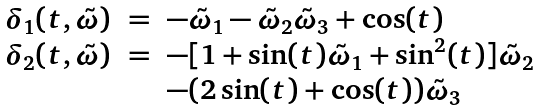<formula> <loc_0><loc_0><loc_500><loc_500>\begin{array} { r c l } \delta _ { 1 } ( t , \tilde { \omega } ) & = & - \tilde { \omega } _ { 1 } - \tilde { \omega } _ { 2 } \tilde { \omega } _ { 3 } + \cos ( t ) \\ \delta _ { 2 } ( t , \tilde { \omega } ) & = & - [ 1 + \sin ( t ) \tilde { \omega } _ { 1 } + \sin ^ { 2 } ( t ) ] \tilde { \omega } _ { 2 } \\ & & - ( 2 \sin ( t ) + \cos ( t ) ) \tilde { \omega } _ { 3 } \end{array}</formula> 